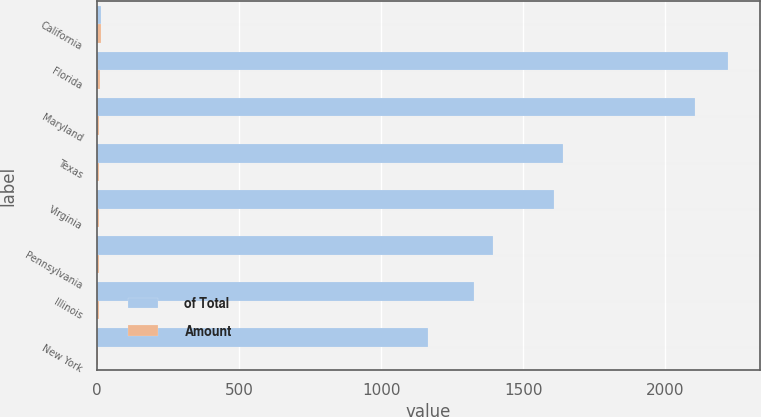<chart> <loc_0><loc_0><loc_500><loc_500><stacked_bar_chart><ecel><fcel>California<fcel>Florida<fcel>Maryland<fcel>Texas<fcel>Virginia<fcel>Pennsylvania<fcel>Illinois<fcel>New York<nl><fcel>of Total<fcel>14<fcel>2221<fcel>2104<fcel>1639<fcel>1609<fcel>1394<fcel>1325<fcel>1163<nl><fcel>Amount<fcel>14<fcel>8<fcel>7<fcel>6<fcel>5<fcel>5<fcel>5<fcel>4<nl></chart> 